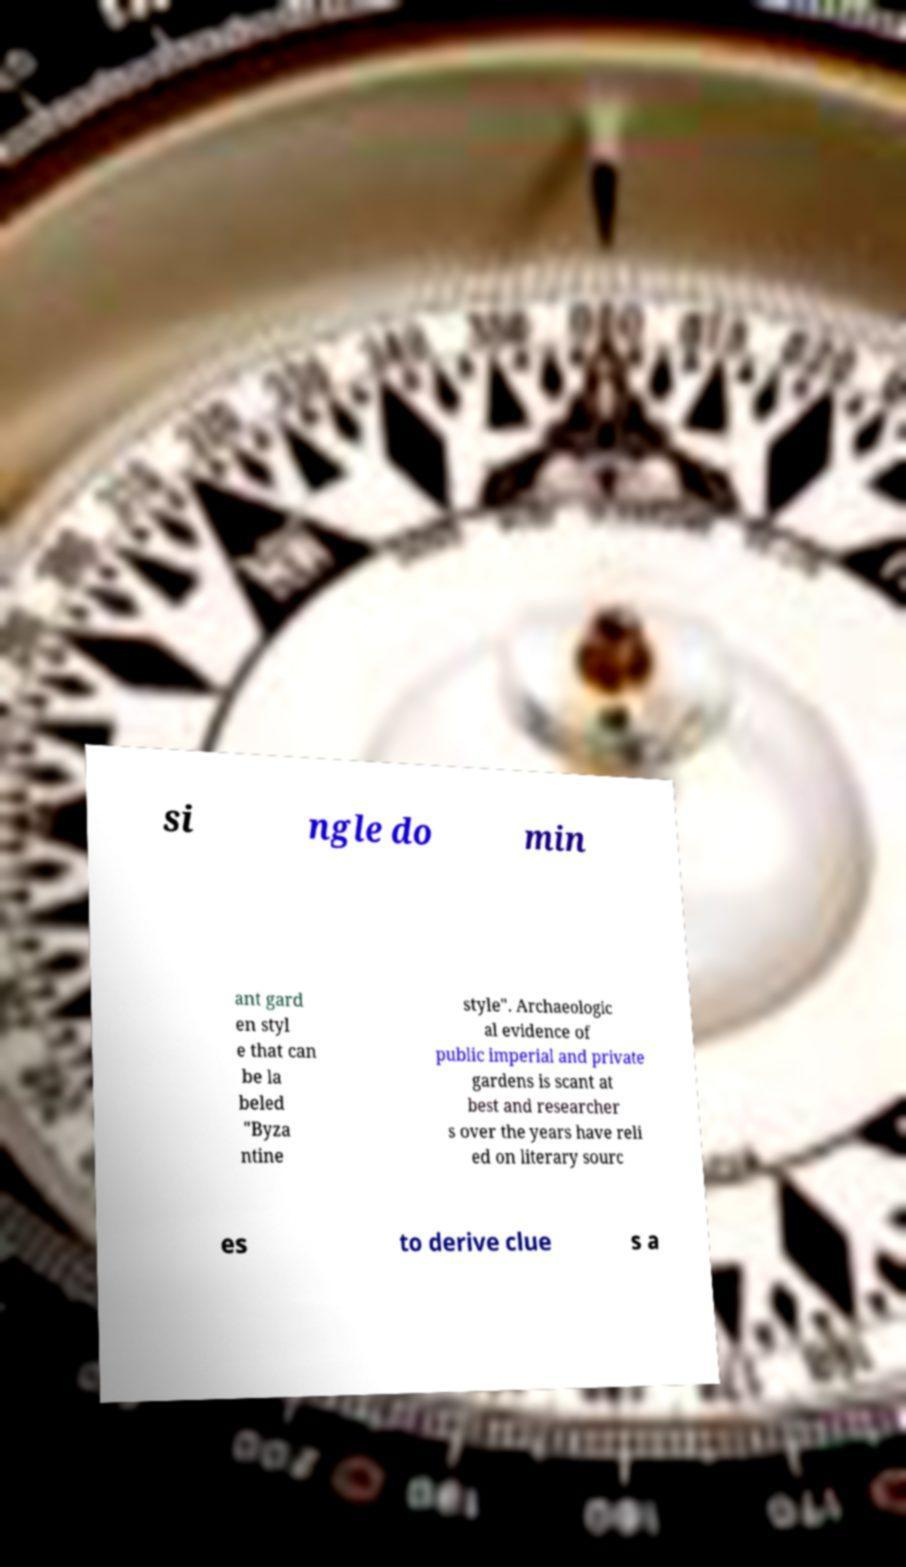I need the written content from this picture converted into text. Can you do that? si ngle do min ant gard en styl e that can be la beled "Byza ntine style". Archaeologic al evidence of public imperial and private gardens is scant at best and researcher s over the years have reli ed on literary sourc es to derive clue s a 